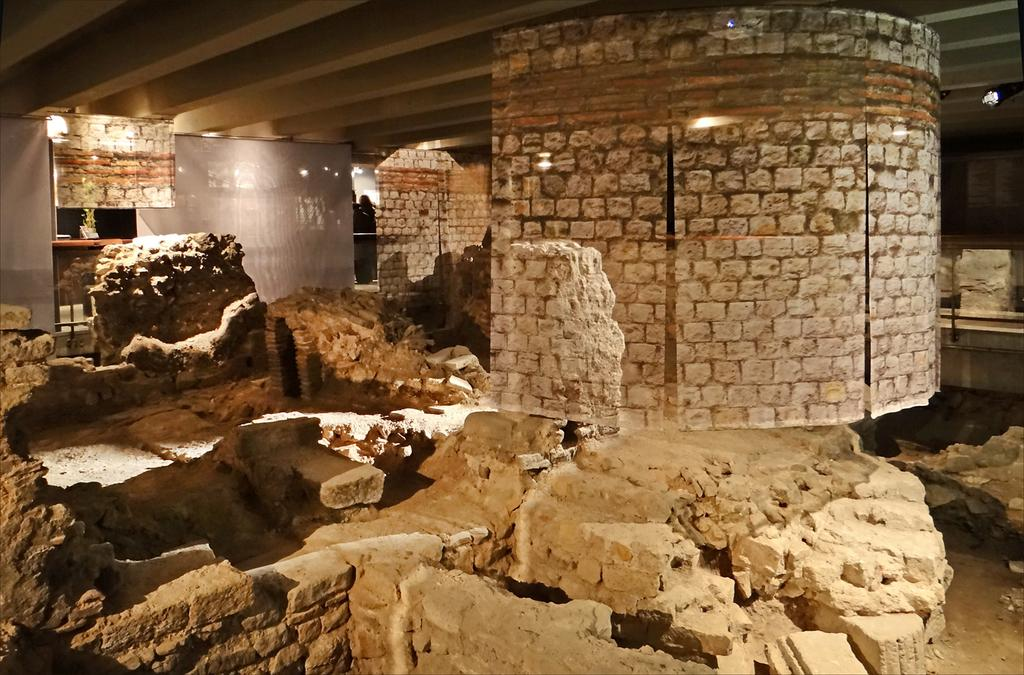What is the condition of the walls in the image? The walls in the image are collapsed. What type of signage is present in the image? There are brick wall banners and boards in the image. What can be seen in the background of the image? In the background, there are clothes, lights, objects, and a few persons visible. What type of squirrel can be seen climbing the collapsed walls in the image? There are no squirrels present in the image; it only features collapsed walls, brick wall banners and boards, and background elements. How many apples are visible on the collapsed walls in the image? There are no apples present in the image; it only features collapsed walls, brick wall banners and boards, and background elements. 